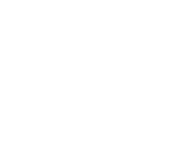Convert code to text. <code><loc_0><loc_0><loc_500><loc_500><_SQL_>
</code> 